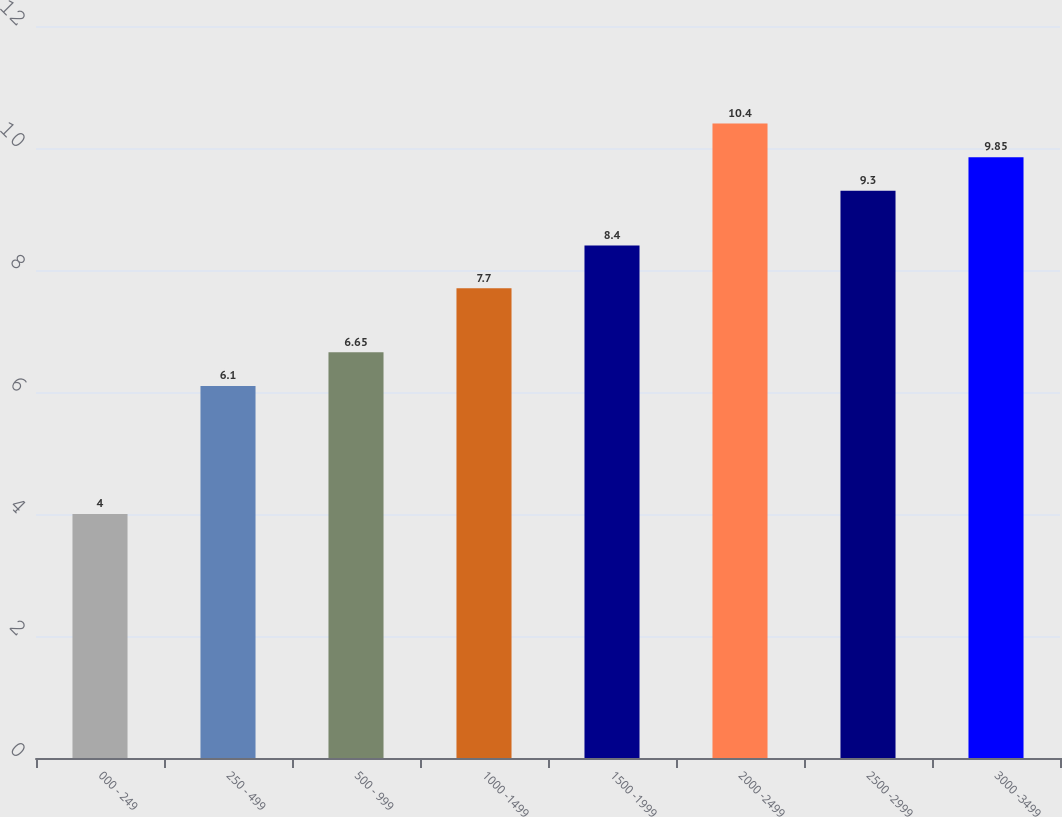Convert chart to OTSL. <chart><loc_0><loc_0><loc_500><loc_500><bar_chart><fcel>000 - 249<fcel>250 - 499<fcel>500 - 999<fcel>1000 -1499<fcel>1500 -1999<fcel>2000 -2499<fcel>2500 -2999<fcel>3000 -3499<nl><fcel>4<fcel>6.1<fcel>6.65<fcel>7.7<fcel>8.4<fcel>10.4<fcel>9.3<fcel>9.85<nl></chart> 